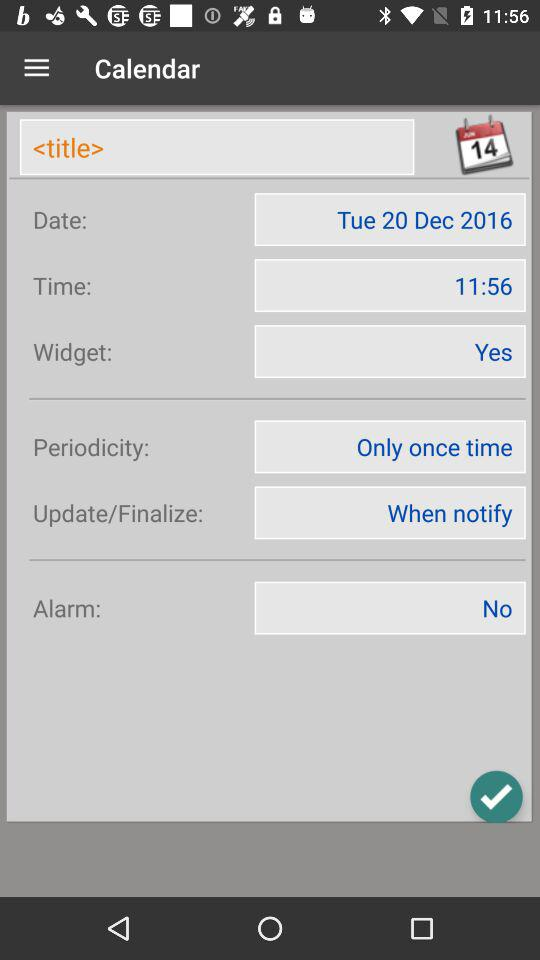What is the application name? The application name is "Calendar". 